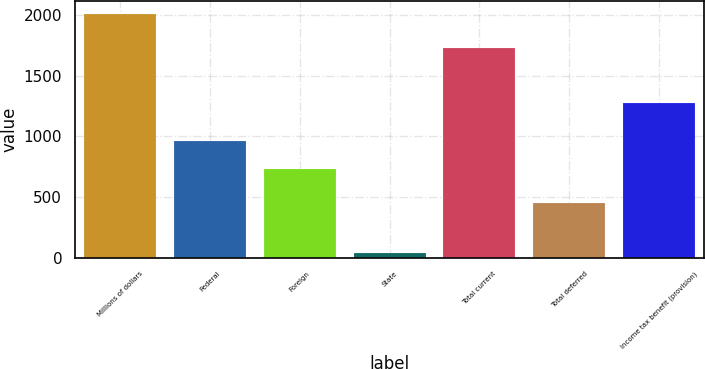<chart> <loc_0><loc_0><loc_500><loc_500><bar_chart><fcel>Millions of dollars<fcel>Federal<fcel>Foreign<fcel>State<fcel>Total current<fcel>Total deferred<fcel>Income tax benefit (provision)<nl><fcel>2014<fcel>959<fcel>734<fcel>36<fcel>1729<fcel>454<fcel>1275<nl></chart> 